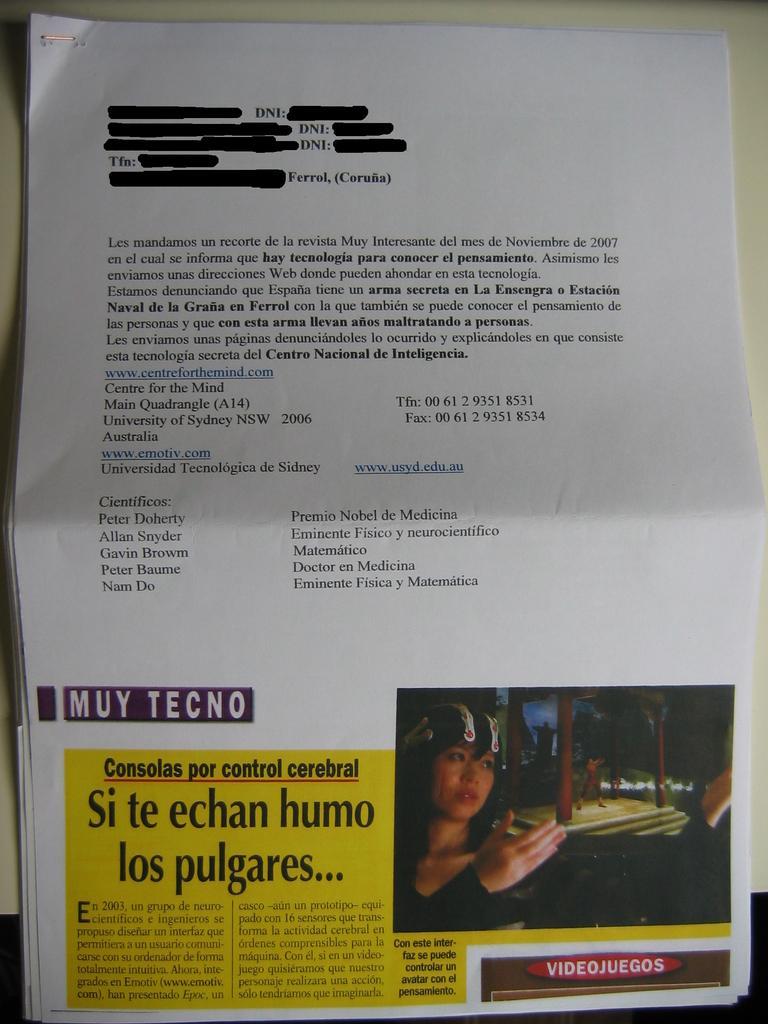How would you summarize this image in a sentence or two? This picture contains a paper with text printed on it, is placed on a white table. 